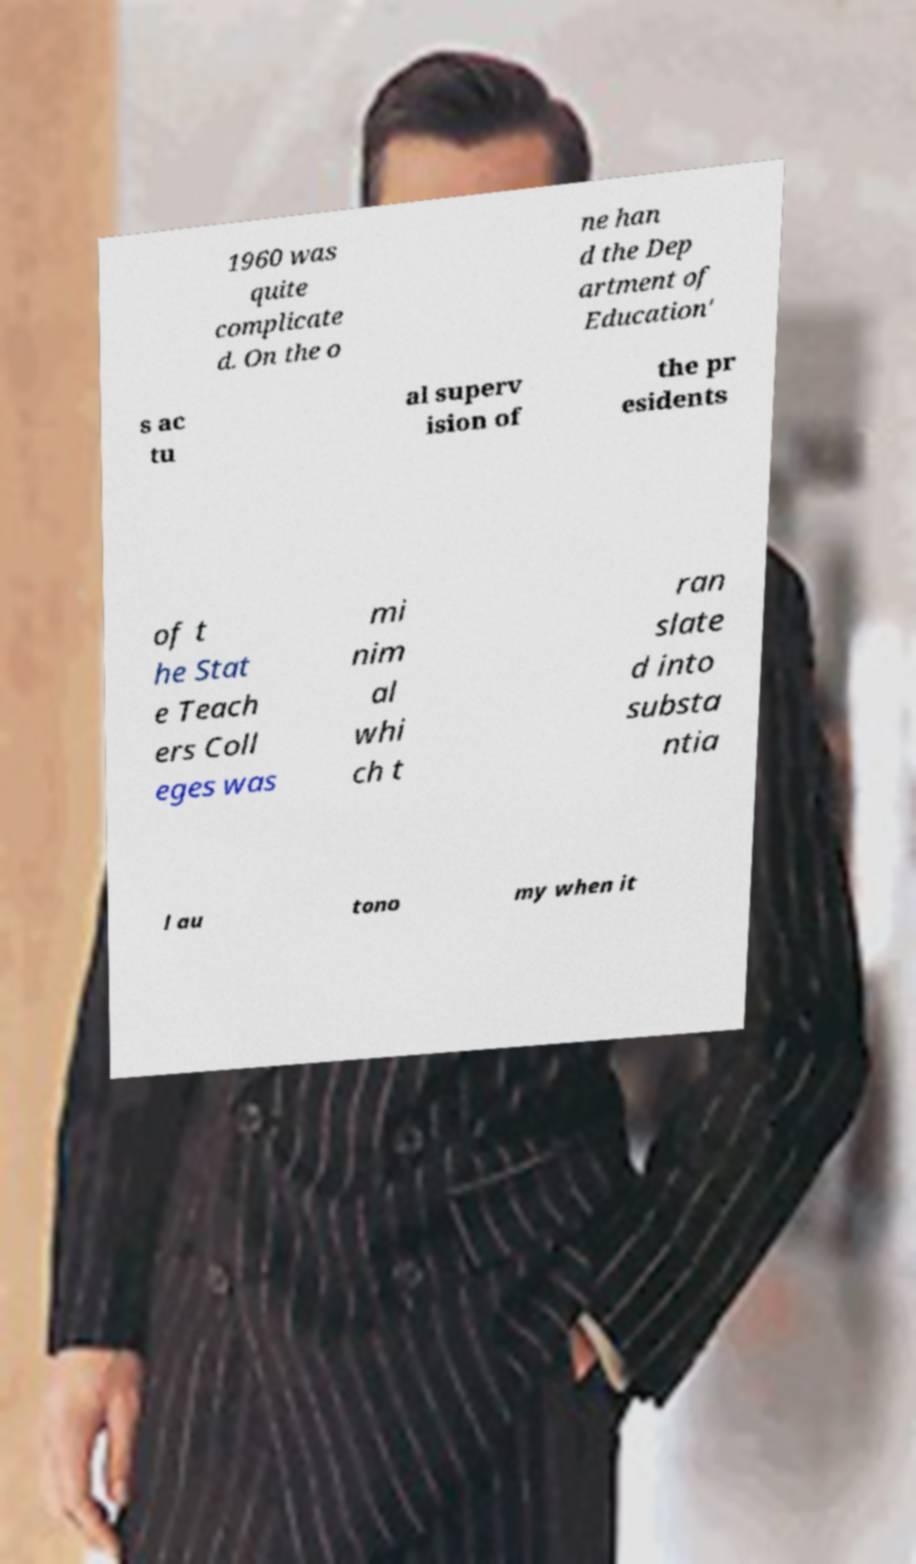I need the written content from this picture converted into text. Can you do that? 1960 was quite complicate d. On the o ne han d the Dep artment of Education' s ac tu al superv ision of the pr esidents of t he Stat e Teach ers Coll eges was mi nim al whi ch t ran slate d into substa ntia l au tono my when it 